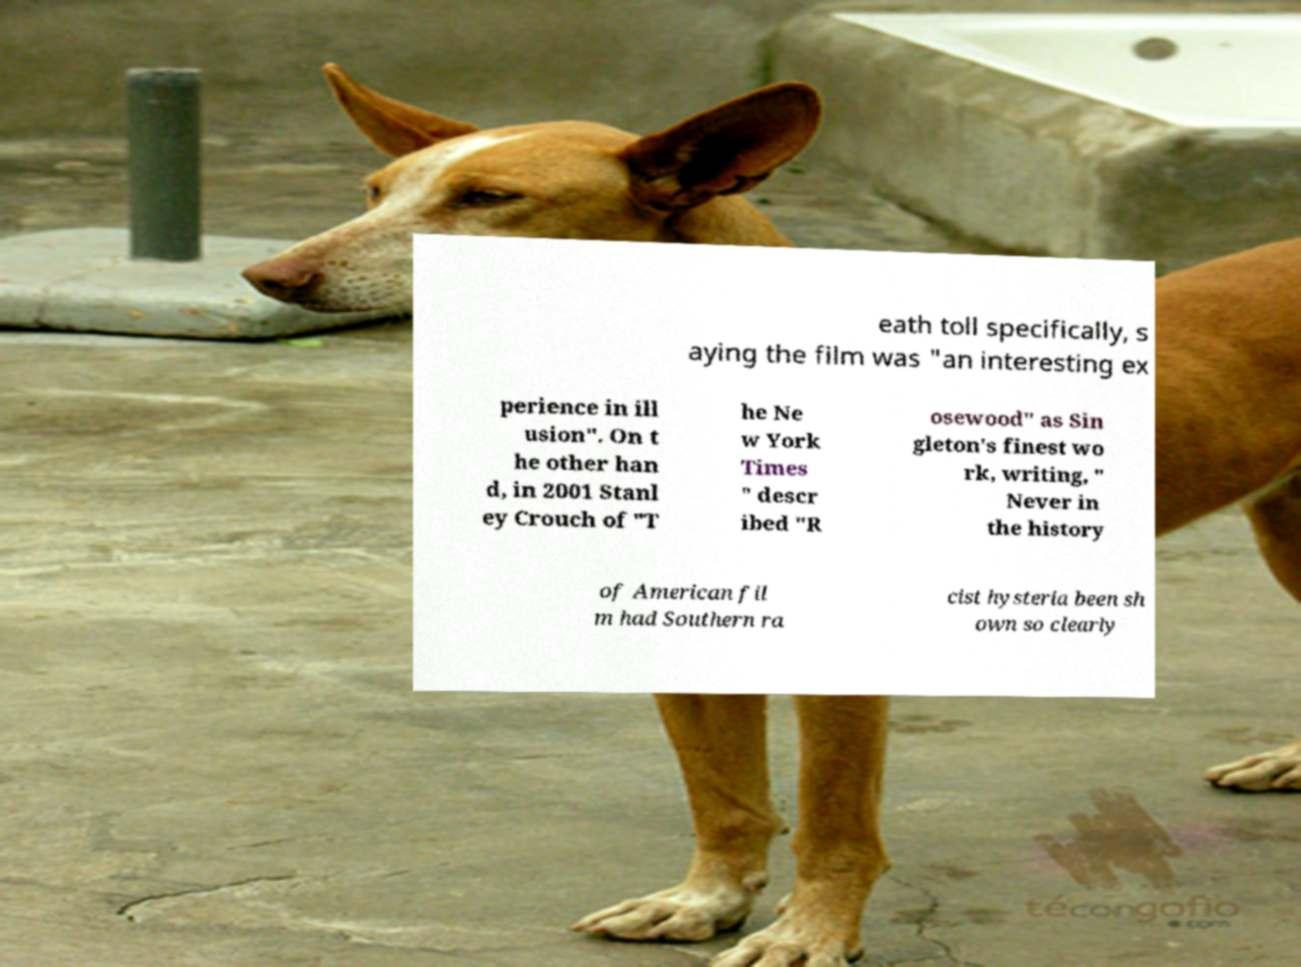Please read and relay the text visible in this image. What does it say? eath toll specifically, s aying the film was "an interesting ex perience in ill usion". On t he other han d, in 2001 Stanl ey Crouch of "T he Ne w York Times " descr ibed "R osewood" as Sin gleton's finest wo rk, writing, " Never in the history of American fil m had Southern ra cist hysteria been sh own so clearly 